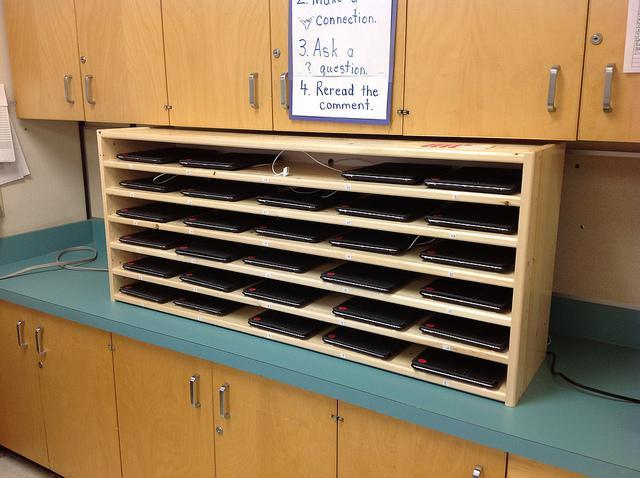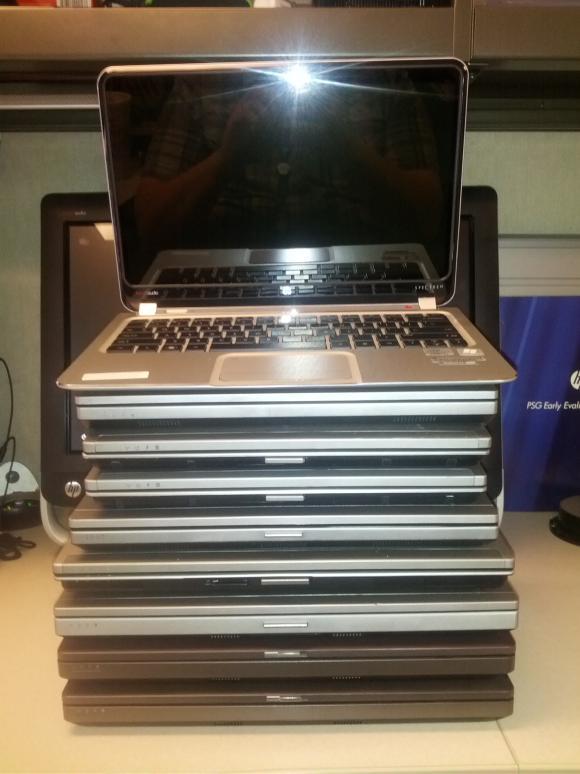The first image is the image on the left, the second image is the image on the right. For the images displayed, is the sentence "All of the computers are sitting flat." factually correct? Answer yes or no. Yes. The first image is the image on the left, the second image is the image on the right. Evaluate the accuracy of this statement regarding the images: "One image shows laptops stacked directly on top of each other, and the other image shows a shelved unit that stores laptops horizontally in multiple rows.". Is it true? Answer yes or no. Yes. 